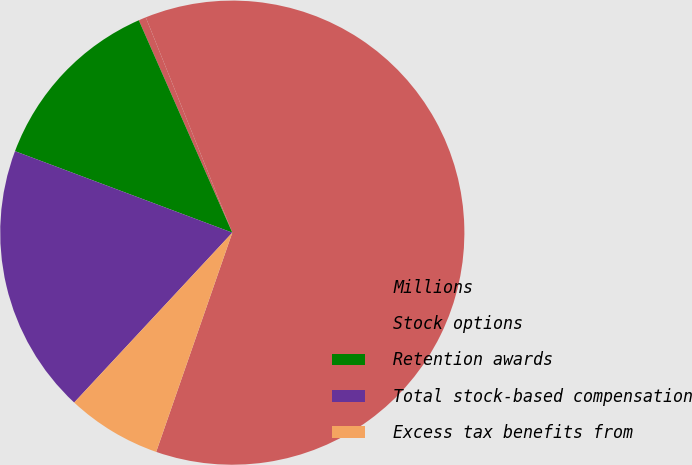Convert chart. <chart><loc_0><loc_0><loc_500><loc_500><pie_chart><fcel>Millions<fcel>Stock options<fcel>Retention awards<fcel>Total stock-based compensation<fcel>Excess tax benefits from<nl><fcel>61.4%<fcel>0.52%<fcel>12.69%<fcel>18.78%<fcel>6.61%<nl></chart> 